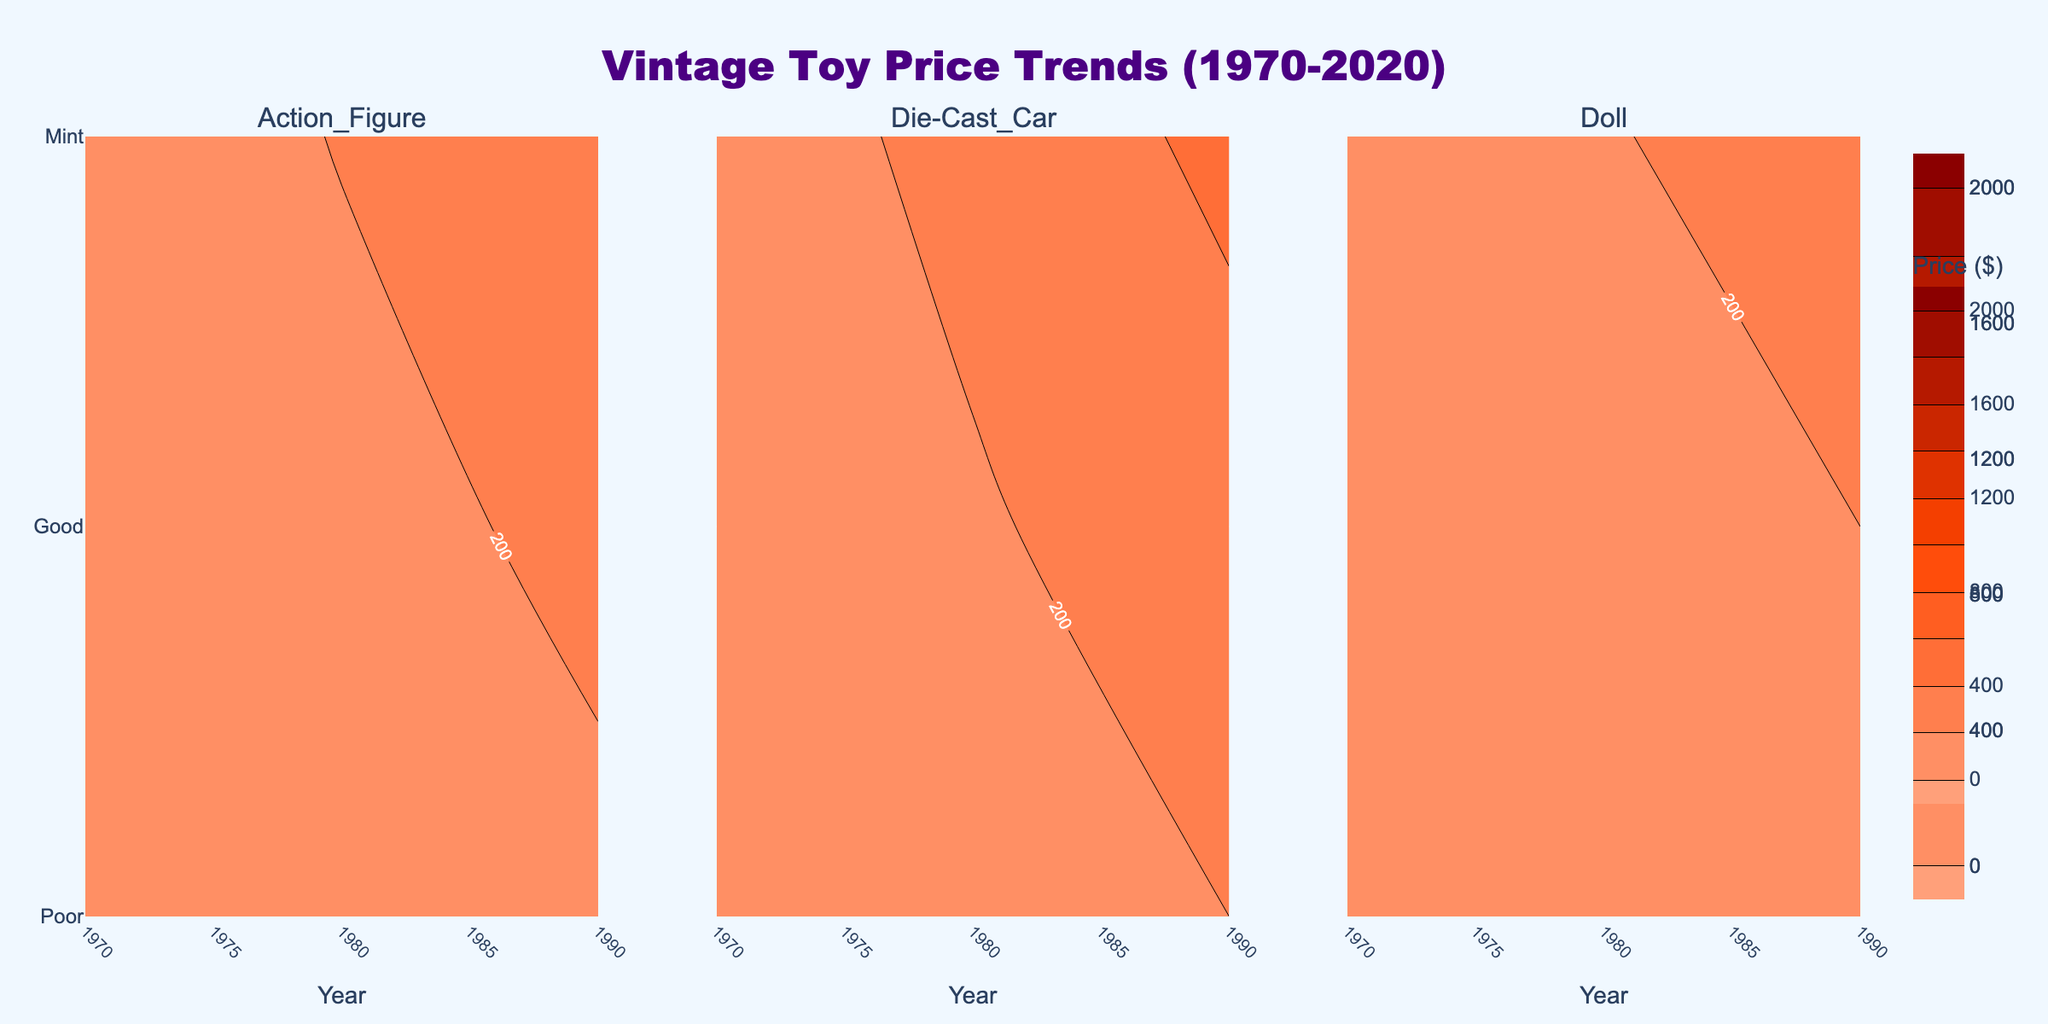what is the title of the figure? The title of the figure is typically displayed at the top of the plot. In this case, it reads "Vintage Toy Price Trends (1970-2020)."
Answer: Vintage Toy Price Trends (1970-2020) how many toy types are compared in the figure? The figure contains three subplot titles, each corresponding to a different toy type.
Answer: 3 which condition has the lowest average price in 2020 for action figures? To answer this, locate the 2020 label along the x-axis under the "Action Figure" subplot and find the condition label (Mint, Good, or Poor) with the lowest price.
Answer: Poor what is the difference in average price between mint condition die-cast cars and dolls in 1990? Find the 1990 label along the x-axis in "Mint" condition for both die-cast cars and dolls, then subtract the doll's average price from the die-cast car's average price.
Answer: 100 which toy type experienced the highest price increase in mint condition from 1970 to 2020? Calculate the price difference from 1970 to 2020 for "Mint" conditions in each toy type and compare these values. The largest number indicates the highest increase.
Answer: Die-Cast Car which condition generally has a darker color in the contours, indicating higher prices? Darker colors in contour plots represent higher prices. Compare the colors across "Poor," "Good," and "Mint" conditions.
Answer: Mint what is the average price for a good condition doll in 2000? Locate the 2000 label along the x-axis in the "Doll" subplot, find the point in the "Good" row, and note the value.
Answer: 270 between 1970 and 1980, which toy type had a smaller rise in average price in good condition? Compare the 1970 and 1980 price values for "Good" conditions in all toy types and determine which has the smallest difference.
Answer: Doll how do prices for vintage toys vary by condition over the years? Observe the variation in contour lines for each toy type over the years across "Poor," "Good," and "Mint" conditions to see how prices change.
Answer: Prices increase with better conditions (Mint > Good > Poor) over the years in which year does the price for a poor condition action figure cross above 100 dollars? Look along the timeline in the "Poor" row under the "Action Figure" subplot and identify the year when the price exceeds $100.
Answer: 2020 